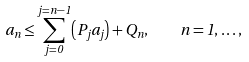Convert formula to latex. <formula><loc_0><loc_0><loc_500><loc_500>a _ { n } \leq \sum _ { j = 0 } ^ { j = n - 1 } \left ( P _ { j } a _ { j } \right ) + Q _ { n } , \quad n = 1 , \dots ,</formula> 